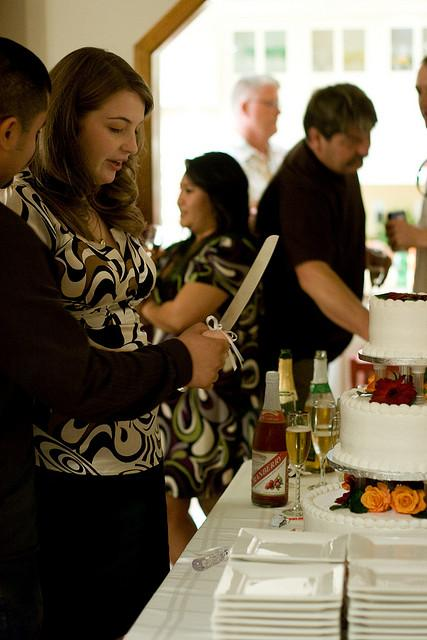What did this lady do on the day she holds this knife?

Choices:
A) butcher pigs
B) divorce
C) become imprisoned
D) marry marry 